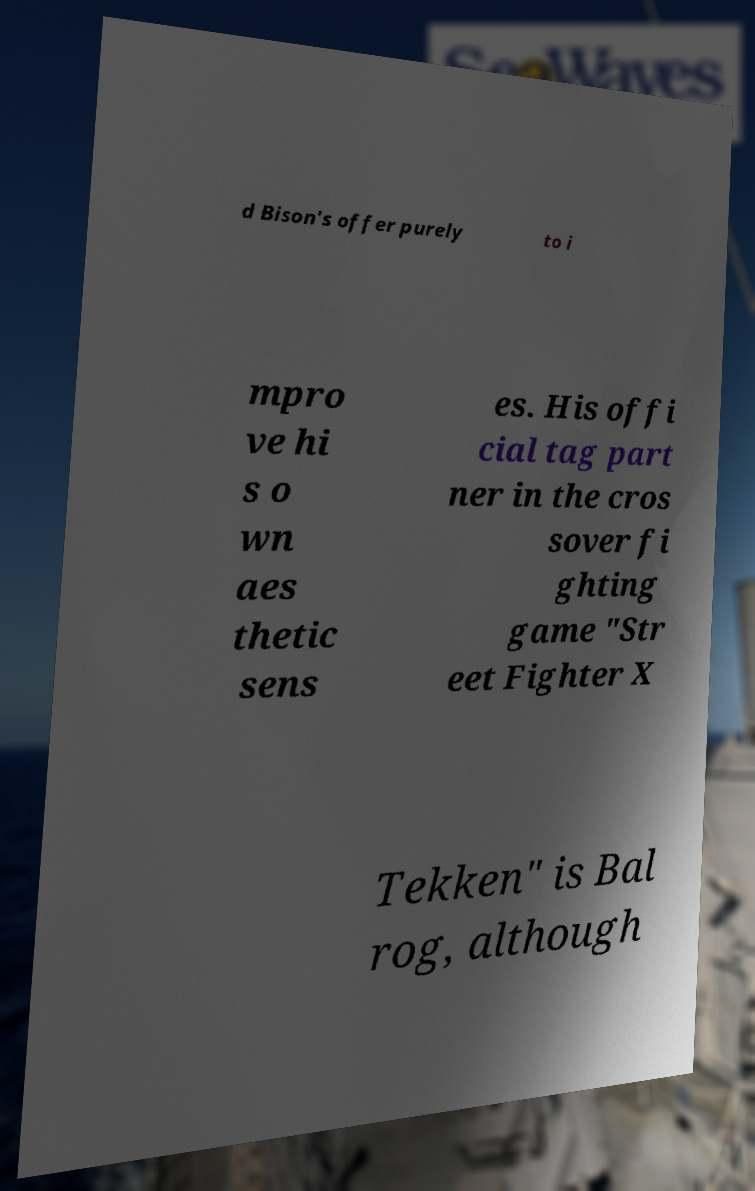I need the written content from this picture converted into text. Can you do that? d Bison's offer purely to i mpro ve hi s o wn aes thetic sens es. His offi cial tag part ner in the cros sover fi ghting game "Str eet Fighter X Tekken" is Bal rog, although 